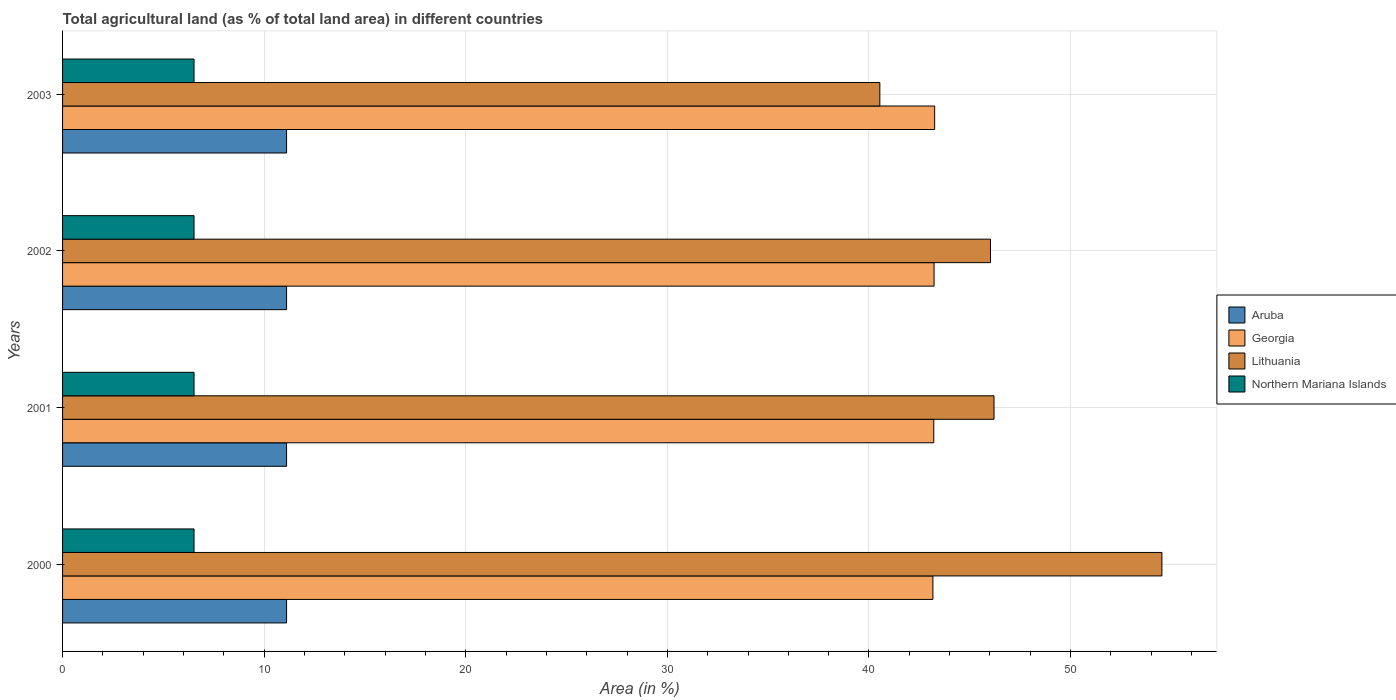How many different coloured bars are there?
Ensure brevity in your answer.  4. Are the number of bars per tick equal to the number of legend labels?
Give a very brief answer. Yes. In how many cases, is the number of bars for a given year not equal to the number of legend labels?
Your answer should be very brief. 0. What is the percentage of agricultural land in Northern Mariana Islands in 2001?
Your answer should be compact. 6.52. Across all years, what is the maximum percentage of agricultural land in Northern Mariana Islands?
Your answer should be compact. 6.52. Across all years, what is the minimum percentage of agricultural land in Aruba?
Your answer should be very brief. 11.11. In which year was the percentage of agricultural land in Northern Mariana Islands maximum?
Give a very brief answer. 2000. What is the total percentage of agricultural land in Georgia in the graph?
Keep it short and to the point. 172.87. What is the difference between the percentage of agricultural land in Northern Mariana Islands in 2001 and that in 2002?
Offer a very short reply. 0. What is the difference between the percentage of agricultural land in Georgia in 2000 and the percentage of agricultural land in Northern Mariana Islands in 2001?
Your response must be concise. 36.65. What is the average percentage of agricultural land in Northern Mariana Islands per year?
Offer a terse response. 6.52. In the year 2000, what is the difference between the percentage of agricultural land in Georgia and percentage of agricultural land in Lithuania?
Provide a succinct answer. -11.36. What is the ratio of the percentage of agricultural land in Northern Mariana Islands in 2000 to that in 2001?
Provide a succinct answer. 1. Is the percentage of agricultural land in Lithuania in 2000 less than that in 2001?
Offer a terse response. No. What is the difference between the highest and the second highest percentage of agricultural land in Georgia?
Keep it short and to the point. 0.03. What is the difference between the highest and the lowest percentage of agricultural land in Lithuania?
Your answer should be very brief. 13.99. What does the 1st bar from the top in 2002 represents?
Your answer should be compact. Northern Mariana Islands. What does the 3rd bar from the bottom in 2003 represents?
Provide a succinct answer. Lithuania. How many bars are there?
Provide a short and direct response. 16. What is the difference between two consecutive major ticks on the X-axis?
Offer a very short reply. 10. Does the graph contain grids?
Your response must be concise. Yes. How many legend labels are there?
Provide a succinct answer. 4. What is the title of the graph?
Your answer should be compact. Total agricultural land (as % of total land area) in different countries. What is the label or title of the X-axis?
Make the answer very short. Area (in %). What is the label or title of the Y-axis?
Ensure brevity in your answer.  Years. What is the Area (in %) of Aruba in 2000?
Give a very brief answer. 11.11. What is the Area (in %) in Georgia in 2000?
Provide a succinct answer. 43.17. What is the Area (in %) in Lithuania in 2000?
Provide a short and direct response. 54.53. What is the Area (in %) in Northern Mariana Islands in 2000?
Offer a very short reply. 6.52. What is the Area (in %) of Aruba in 2001?
Ensure brevity in your answer.  11.11. What is the Area (in %) of Georgia in 2001?
Provide a succinct answer. 43.21. What is the Area (in %) of Lithuania in 2001?
Provide a succinct answer. 46.2. What is the Area (in %) in Northern Mariana Islands in 2001?
Your answer should be very brief. 6.52. What is the Area (in %) of Aruba in 2002?
Ensure brevity in your answer.  11.11. What is the Area (in %) in Georgia in 2002?
Your response must be concise. 43.23. What is the Area (in %) in Lithuania in 2002?
Your answer should be very brief. 46.03. What is the Area (in %) in Northern Mariana Islands in 2002?
Make the answer very short. 6.52. What is the Area (in %) of Aruba in 2003?
Offer a terse response. 11.11. What is the Area (in %) in Georgia in 2003?
Provide a short and direct response. 43.26. What is the Area (in %) of Lithuania in 2003?
Offer a terse response. 40.54. What is the Area (in %) of Northern Mariana Islands in 2003?
Keep it short and to the point. 6.52. Across all years, what is the maximum Area (in %) of Aruba?
Offer a very short reply. 11.11. Across all years, what is the maximum Area (in %) of Georgia?
Your response must be concise. 43.26. Across all years, what is the maximum Area (in %) of Lithuania?
Your answer should be compact. 54.53. Across all years, what is the maximum Area (in %) in Northern Mariana Islands?
Give a very brief answer. 6.52. Across all years, what is the minimum Area (in %) of Aruba?
Ensure brevity in your answer.  11.11. Across all years, what is the minimum Area (in %) of Georgia?
Provide a succinct answer. 43.17. Across all years, what is the minimum Area (in %) of Lithuania?
Your answer should be compact. 40.54. Across all years, what is the minimum Area (in %) of Northern Mariana Islands?
Provide a succinct answer. 6.52. What is the total Area (in %) in Aruba in the graph?
Give a very brief answer. 44.44. What is the total Area (in %) in Georgia in the graph?
Offer a terse response. 172.87. What is the total Area (in %) of Lithuania in the graph?
Offer a terse response. 187.3. What is the total Area (in %) in Northern Mariana Islands in the graph?
Keep it short and to the point. 26.09. What is the difference between the Area (in %) in Aruba in 2000 and that in 2001?
Your answer should be very brief. 0. What is the difference between the Area (in %) in Georgia in 2000 and that in 2001?
Your answer should be very brief. -0.04. What is the difference between the Area (in %) of Lithuania in 2000 and that in 2001?
Offer a terse response. 8.33. What is the difference between the Area (in %) of Aruba in 2000 and that in 2002?
Keep it short and to the point. 0. What is the difference between the Area (in %) in Georgia in 2000 and that in 2002?
Give a very brief answer. -0.06. What is the difference between the Area (in %) of Lithuania in 2000 and that in 2002?
Offer a terse response. 8.5. What is the difference between the Area (in %) of Georgia in 2000 and that in 2003?
Your answer should be very brief. -0.09. What is the difference between the Area (in %) of Lithuania in 2000 and that in 2003?
Give a very brief answer. 13.99. What is the difference between the Area (in %) of Northern Mariana Islands in 2000 and that in 2003?
Provide a succinct answer. 0. What is the difference between the Area (in %) of Aruba in 2001 and that in 2002?
Offer a terse response. 0. What is the difference between the Area (in %) of Georgia in 2001 and that in 2002?
Provide a short and direct response. -0.01. What is the difference between the Area (in %) of Lithuania in 2001 and that in 2002?
Provide a short and direct response. 0.18. What is the difference between the Area (in %) in Northern Mariana Islands in 2001 and that in 2002?
Provide a succinct answer. 0. What is the difference between the Area (in %) in Aruba in 2001 and that in 2003?
Provide a short and direct response. 0. What is the difference between the Area (in %) of Georgia in 2001 and that in 2003?
Ensure brevity in your answer.  -0.04. What is the difference between the Area (in %) of Lithuania in 2001 and that in 2003?
Your response must be concise. 5.66. What is the difference between the Area (in %) in Northern Mariana Islands in 2001 and that in 2003?
Provide a short and direct response. 0. What is the difference between the Area (in %) in Aruba in 2002 and that in 2003?
Ensure brevity in your answer.  0. What is the difference between the Area (in %) in Georgia in 2002 and that in 2003?
Provide a short and direct response. -0.03. What is the difference between the Area (in %) of Lithuania in 2002 and that in 2003?
Offer a very short reply. 5.49. What is the difference between the Area (in %) in Aruba in 2000 and the Area (in %) in Georgia in 2001?
Provide a short and direct response. -32.1. What is the difference between the Area (in %) in Aruba in 2000 and the Area (in %) in Lithuania in 2001?
Your answer should be very brief. -35.09. What is the difference between the Area (in %) of Aruba in 2000 and the Area (in %) of Northern Mariana Islands in 2001?
Provide a short and direct response. 4.59. What is the difference between the Area (in %) in Georgia in 2000 and the Area (in %) in Lithuania in 2001?
Offer a very short reply. -3.03. What is the difference between the Area (in %) in Georgia in 2000 and the Area (in %) in Northern Mariana Islands in 2001?
Provide a succinct answer. 36.65. What is the difference between the Area (in %) of Lithuania in 2000 and the Area (in %) of Northern Mariana Islands in 2001?
Offer a terse response. 48.01. What is the difference between the Area (in %) of Aruba in 2000 and the Area (in %) of Georgia in 2002?
Make the answer very short. -32.12. What is the difference between the Area (in %) of Aruba in 2000 and the Area (in %) of Lithuania in 2002?
Keep it short and to the point. -34.92. What is the difference between the Area (in %) of Aruba in 2000 and the Area (in %) of Northern Mariana Islands in 2002?
Make the answer very short. 4.59. What is the difference between the Area (in %) of Georgia in 2000 and the Area (in %) of Lithuania in 2002?
Offer a terse response. -2.86. What is the difference between the Area (in %) of Georgia in 2000 and the Area (in %) of Northern Mariana Islands in 2002?
Offer a very short reply. 36.65. What is the difference between the Area (in %) in Lithuania in 2000 and the Area (in %) in Northern Mariana Islands in 2002?
Ensure brevity in your answer.  48.01. What is the difference between the Area (in %) of Aruba in 2000 and the Area (in %) of Georgia in 2003?
Ensure brevity in your answer.  -32.15. What is the difference between the Area (in %) of Aruba in 2000 and the Area (in %) of Lithuania in 2003?
Give a very brief answer. -29.43. What is the difference between the Area (in %) of Aruba in 2000 and the Area (in %) of Northern Mariana Islands in 2003?
Ensure brevity in your answer.  4.59. What is the difference between the Area (in %) in Georgia in 2000 and the Area (in %) in Lithuania in 2003?
Give a very brief answer. 2.63. What is the difference between the Area (in %) in Georgia in 2000 and the Area (in %) in Northern Mariana Islands in 2003?
Your response must be concise. 36.65. What is the difference between the Area (in %) in Lithuania in 2000 and the Area (in %) in Northern Mariana Islands in 2003?
Your answer should be very brief. 48.01. What is the difference between the Area (in %) of Aruba in 2001 and the Area (in %) of Georgia in 2002?
Make the answer very short. -32.12. What is the difference between the Area (in %) of Aruba in 2001 and the Area (in %) of Lithuania in 2002?
Make the answer very short. -34.92. What is the difference between the Area (in %) in Aruba in 2001 and the Area (in %) in Northern Mariana Islands in 2002?
Ensure brevity in your answer.  4.59. What is the difference between the Area (in %) of Georgia in 2001 and the Area (in %) of Lithuania in 2002?
Your answer should be compact. -2.81. What is the difference between the Area (in %) of Georgia in 2001 and the Area (in %) of Northern Mariana Islands in 2002?
Offer a very short reply. 36.69. What is the difference between the Area (in %) of Lithuania in 2001 and the Area (in %) of Northern Mariana Islands in 2002?
Provide a short and direct response. 39.68. What is the difference between the Area (in %) of Aruba in 2001 and the Area (in %) of Georgia in 2003?
Ensure brevity in your answer.  -32.15. What is the difference between the Area (in %) in Aruba in 2001 and the Area (in %) in Lithuania in 2003?
Keep it short and to the point. -29.43. What is the difference between the Area (in %) in Aruba in 2001 and the Area (in %) in Northern Mariana Islands in 2003?
Provide a succinct answer. 4.59. What is the difference between the Area (in %) in Georgia in 2001 and the Area (in %) in Lithuania in 2003?
Offer a very short reply. 2.68. What is the difference between the Area (in %) of Georgia in 2001 and the Area (in %) of Northern Mariana Islands in 2003?
Make the answer very short. 36.69. What is the difference between the Area (in %) in Lithuania in 2001 and the Area (in %) in Northern Mariana Islands in 2003?
Provide a succinct answer. 39.68. What is the difference between the Area (in %) in Aruba in 2002 and the Area (in %) in Georgia in 2003?
Give a very brief answer. -32.15. What is the difference between the Area (in %) in Aruba in 2002 and the Area (in %) in Lithuania in 2003?
Offer a very short reply. -29.43. What is the difference between the Area (in %) of Aruba in 2002 and the Area (in %) of Northern Mariana Islands in 2003?
Your response must be concise. 4.59. What is the difference between the Area (in %) in Georgia in 2002 and the Area (in %) in Lithuania in 2003?
Keep it short and to the point. 2.69. What is the difference between the Area (in %) in Georgia in 2002 and the Area (in %) in Northern Mariana Islands in 2003?
Offer a very short reply. 36.71. What is the difference between the Area (in %) in Lithuania in 2002 and the Area (in %) in Northern Mariana Islands in 2003?
Your response must be concise. 39.51. What is the average Area (in %) of Aruba per year?
Provide a succinct answer. 11.11. What is the average Area (in %) in Georgia per year?
Give a very brief answer. 43.22. What is the average Area (in %) in Lithuania per year?
Your response must be concise. 46.83. What is the average Area (in %) in Northern Mariana Islands per year?
Your response must be concise. 6.52. In the year 2000, what is the difference between the Area (in %) of Aruba and Area (in %) of Georgia?
Offer a very short reply. -32.06. In the year 2000, what is the difference between the Area (in %) of Aruba and Area (in %) of Lithuania?
Keep it short and to the point. -43.42. In the year 2000, what is the difference between the Area (in %) in Aruba and Area (in %) in Northern Mariana Islands?
Make the answer very short. 4.59. In the year 2000, what is the difference between the Area (in %) of Georgia and Area (in %) of Lithuania?
Provide a succinct answer. -11.36. In the year 2000, what is the difference between the Area (in %) in Georgia and Area (in %) in Northern Mariana Islands?
Keep it short and to the point. 36.65. In the year 2000, what is the difference between the Area (in %) of Lithuania and Area (in %) of Northern Mariana Islands?
Provide a short and direct response. 48.01. In the year 2001, what is the difference between the Area (in %) of Aruba and Area (in %) of Georgia?
Offer a very short reply. -32.1. In the year 2001, what is the difference between the Area (in %) in Aruba and Area (in %) in Lithuania?
Make the answer very short. -35.09. In the year 2001, what is the difference between the Area (in %) of Aruba and Area (in %) of Northern Mariana Islands?
Provide a short and direct response. 4.59. In the year 2001, what is the difference between the Area (in %) in Georgia and Area (in %) in Lithuania?
Ensure brevity in your answer.  -2.99. In the year 2001, what is the difference between the Area (in %) in Georgia and Area (in %) in Northern Mariana Islands?
Offer a terse response. 36.69. In the year 2001, what is the difference between the Area (in %) in Lithuania and Area (in %) in Northern Mariana Islands?
Keep it short and to the point. 39.68. In the year 2002, what is the difference between the Area (in %) in Aruba and Area (in %) in Georgia?
Your answer should be compact. -32.12. In the year 2002, what is the difference between the Area (in %) in Aruba and Area (in %) in Lithuania?
Keep it short and to the point. -34.92. In the year 2002, what is the difference between the Area (in %) of Aruba and Area (in %) of Northern Mariana Islands?
Your response must be concise. 4.59. In the year 2002, what is the difference between the Area (in %) of Georgia and Area (in %) of Lithuania?
Your answer should be very brief. -2.8. In the year 2002, what is the difference between the Area (in %) of Georgia and Area (in %) of Northern Mariana Islands?
Your response must be concise. 36.71. In the year 2002, what is the difference between the Area (in %) in Lithuania and Area (in %) in Northern Mariana Islands?
Your response must be concise. 39.51. In the year 2003, what is the difference between the Area (in %) in Aruba and Area (in %) in Georgia?
Offer a very short reply. -32.15. In the year 2003, what is the difference between the Area (in %) in Aruba and Area (in %) in Lithuania?
Give a very brief answer. -29.43. In the year 2003, what is the difference between the Area (in %) of Aruba and Area (in %) of Northern Mariana Islands?
Your answer should be very brief. 4.59. In the year 2003, what is the difference between the Area (in %) of Georgia and Area (in %) of Lithuania?
Offer a very short reply. 2.72. In the year 2003, what is the difference between the Area (in %) in Georgia and Area (in %) in Northern Mariana Islands?
Offer a terse response. 36.74. In the year 2003, what is the difference between the Area (in %) in Lithuania and Area (in %) in Northern Mariana Islands?
Keep it short and to the point. 34.02. What is the ratio of the Area (in %) in Aruba in 2000 to that in 2001?
Provide a short and direct response. 1. What is the ratio of the Area (in %) in Georgia in 2000 to that in 2001?
Offer a very short reply. 1. What is the ratio of the Area (in %) of Lithuania in 2000 to that in 2001?
Your answer should be compact. 1.18. What is the ratio of the Area (in %) in Georgia in 2000 to that in 2002?
Offer a very short reply. 1. What is the ratio of the Area (in %) of Lithuania in 2000 to that in 2002?
Offer a very short reply. 1.18. What is the ratio of the Area (in %) in Northern Mariana Islands in 2000 to that in 2002?
Provide a succinct answer. 1. What is the ratio of the Area (in %) in Georgia in 2000 to that in 2003?
Make the answer very short. 1. What is the ratio of the Area (in %) in Lithuania in 2000 to that in 2003?
Your response must be concise. 1.35. What is the ratio of the Area (in %) of Northern Mariana Islands in 2000 to that in 2003?
Your answer should be compact. 1. What is the ratio of the Area (in %) in Aruba in 2001 to that in 2002?
Provide a short and direct response. 1. What is the ratio of the Area (in %) of Aruba in 2001 to that in 2003?
Give a very brief answer. 1. What is the ratio of the Area (in %) of Georgia in 2001 to that in 2003?
Offer a very short reply. 1. What is the ratio of the Area (in %) of Lithuania in 2001 to that in 2003?
Offer a very short reply. 1.14. What is the ratio of the Area (in %) in Northern Mariana Islands in 2001 to that in 2003?
Make the answer very short. 1. What is the ratio of the Area (in %) in Georgia in 2002 to that in 2003?
Your answer should be very brief. 1. What is the ratio of the Area (in %) in Lithuania in 2002 to that in 2003?
Your response must be concise. 1.14. What is the difference between the highest and the second highest Area (in %) in Georgia?
Give a very brief answer. 0.03. What is the difference between the highest and the second highest Area (in %) of Lithuania?
Ensure brevity in your answer.  8.33. What is the difference between the highest and the second highest Area (in %) of Northern Mariana Islands?
Keep it short and to the point. 0. What is the difference between the highest and the lowest Area (in %) in Georgia?
Provide a succinct answer. 0.09. What is the difference between the highest and the lowest Area (in %) in Lithuania?
Make the answer very short. 13.99. 